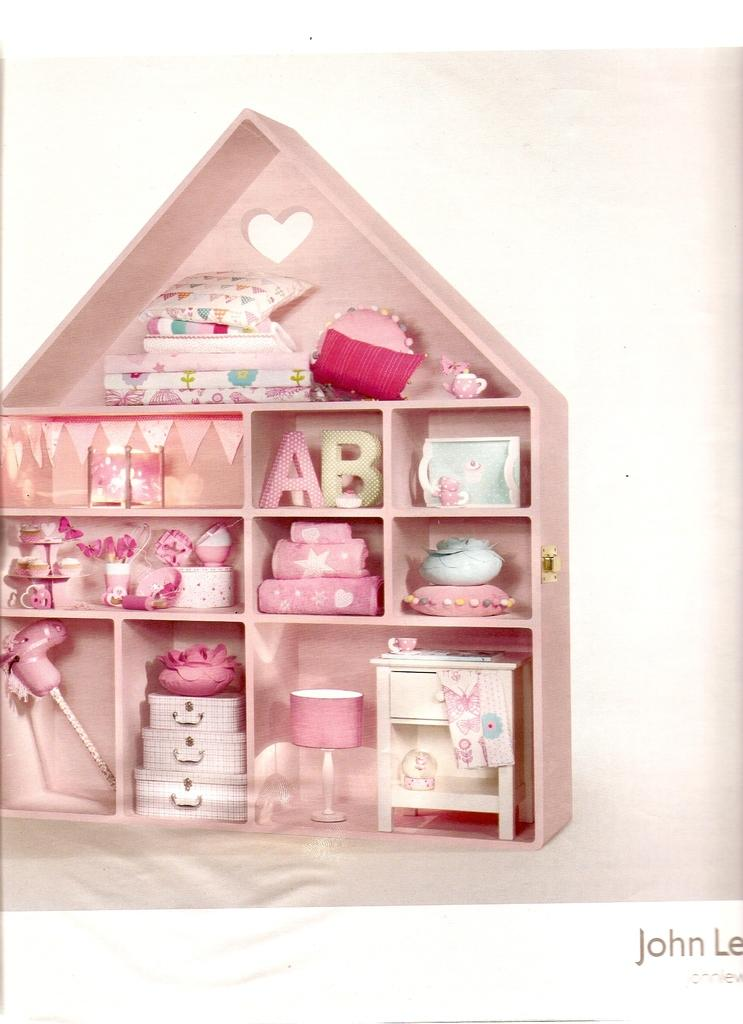What is the main feature of the image? The main feature of the image is a shelf with objects placed on it. What can be observed about the color of most objects on the shelf? Most of the objects on the shelf are pink in color. What is the color of the background in the image? The background of the image is white. Can you hear the sound of the lead being melted in the image? There is no lead or any indication of melting in the image, so it is not possible to hear any related sounds. 